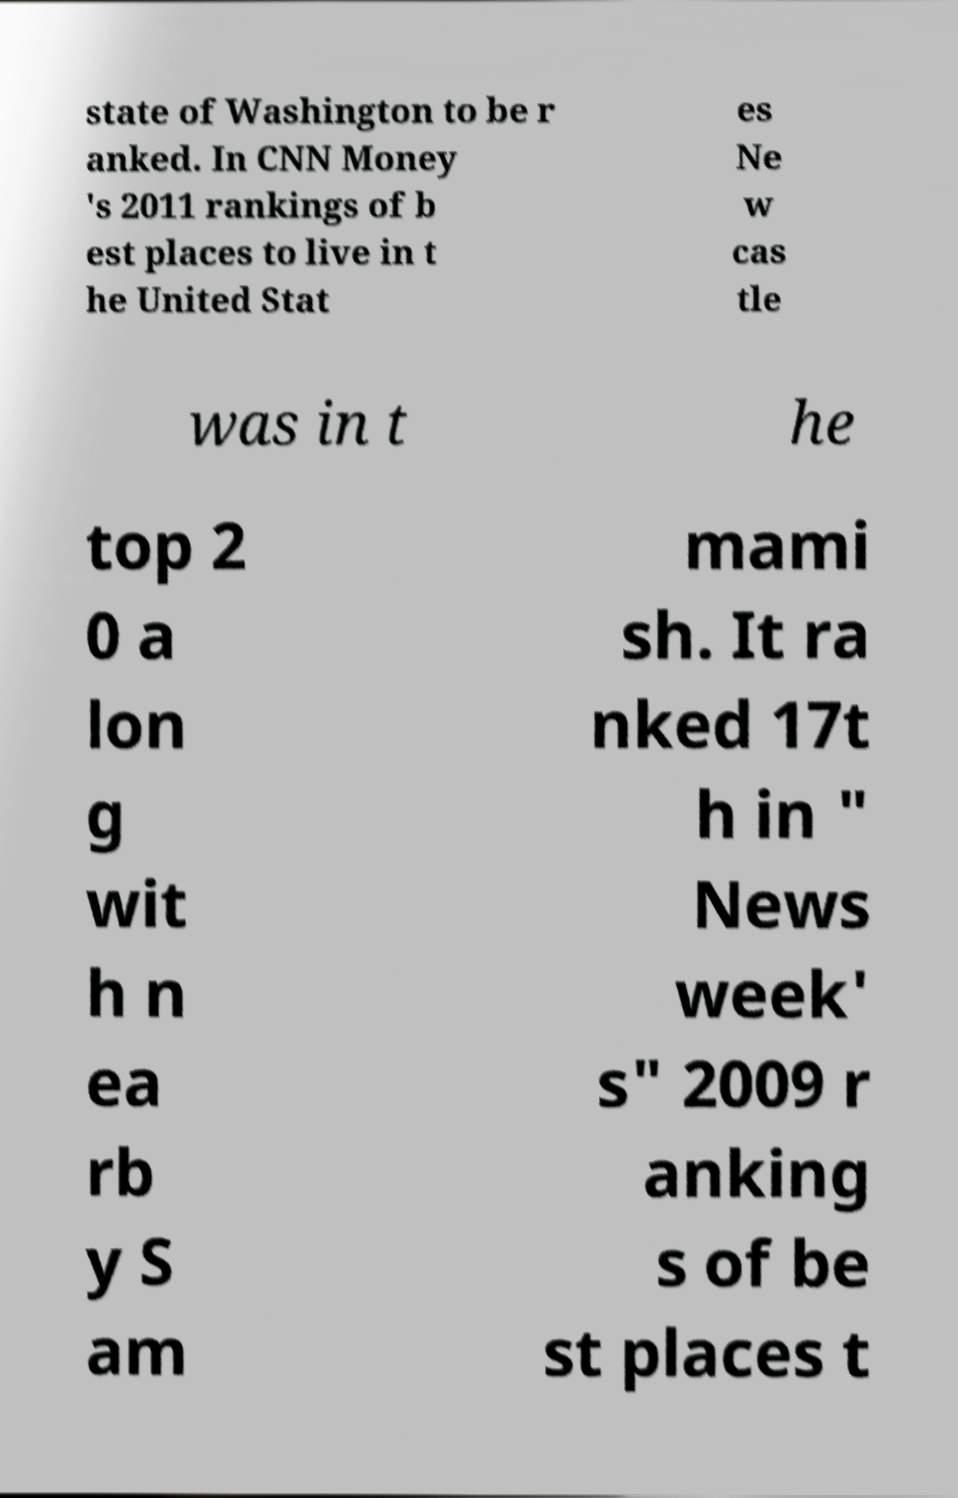Can you read and provide the text displayed in the image?This photo seems to have some interesting text. Can you extract and type it out for me? state of Washington to be r anked. In CNN Money 's 2011 rankings of b est places to live in t he United Stat es Ne w cas tle was in t he top 2 0 a lon g wit h n ea rb y S am mami sh. It ra nked 17t h in " News week' s" 2009 r anking s of be st places t 